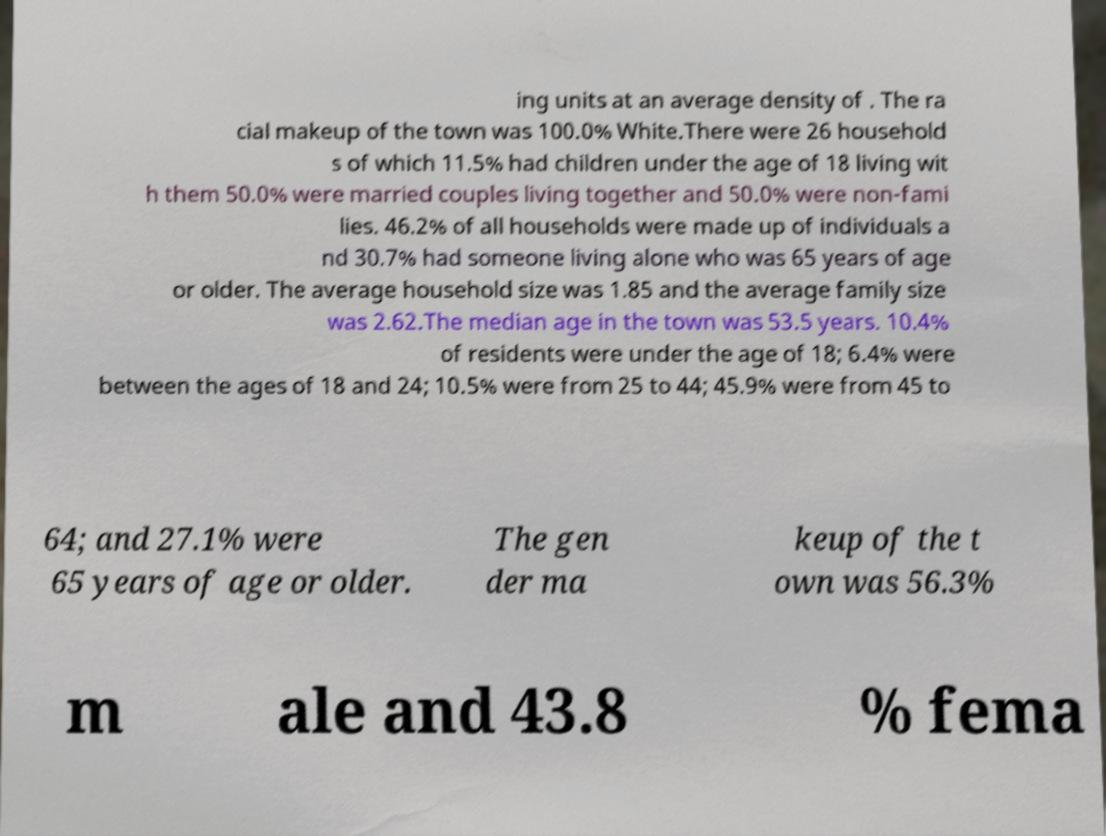Can you read and provide the text displayed in the image?This photo seems to have some interesting text. Can you extract and type it out for me? ing units at an average density of . The ra cial makeup of the town was 100.0% White.There were 26 household s of which 11.5% had children under the age of 18 living wit h them 50.0% were married couples living together and 50.0% were non-fami lies. 46.2% of all households were made up of individuals a nd 30.7% had someone living alone who was 65 years of age or older. The average household size was 1.85 and the average family size was 2.62.The median age in the town was 53.5 years. 10.4% of residents were under the age of 18; 6.4% were between the ages of 18 and 24; 10.5% were from 25 to 44; 45.9% were from 45 to 64; and 27.1% were 65 years of age or older. The gen der ma keup of the t own was 56.3% m ale and 43.8 % fema 